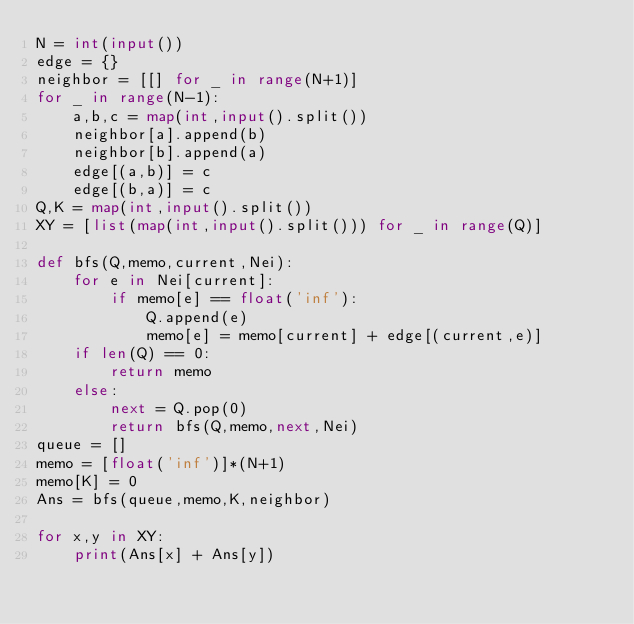Convert code to text. <code><loc_0><loc_0><loc_500><loc_500><_Python_>N = int(input())
edge = {}
neighbor = [[] for _ in range(N+1)]
for _ in range(N-1):
    a,b,c = map(int,input().split())
    neighbor[a].append(b)
    neighbor[b].append(a)
    edge[(a,b)] = c
    edge[(b,a)] = c
Q,K = map(int,input().split())
XY = [list(map(int,input().split())) for _ in range(Q)]

def bfs(Q,memo,current,Nei):
    for e in Nei[current]:
        if memo[e] == float('inf'):
            Q.append(e)
            memo[e] = memo[current] + edge[(current,e)]
    if len(Q) == 0:
        return memo
    else:
        next = Q.pop(0)
        return bfs(Q,memo,next,Nei)
queue = []
memo = [float('inf')]*(N+1)
memo[K] = 0
Ans = bfs(queue,memo,K,neighbor)

for x,y in XY:
    print(Ans[x] + Ans[y])
</code> 